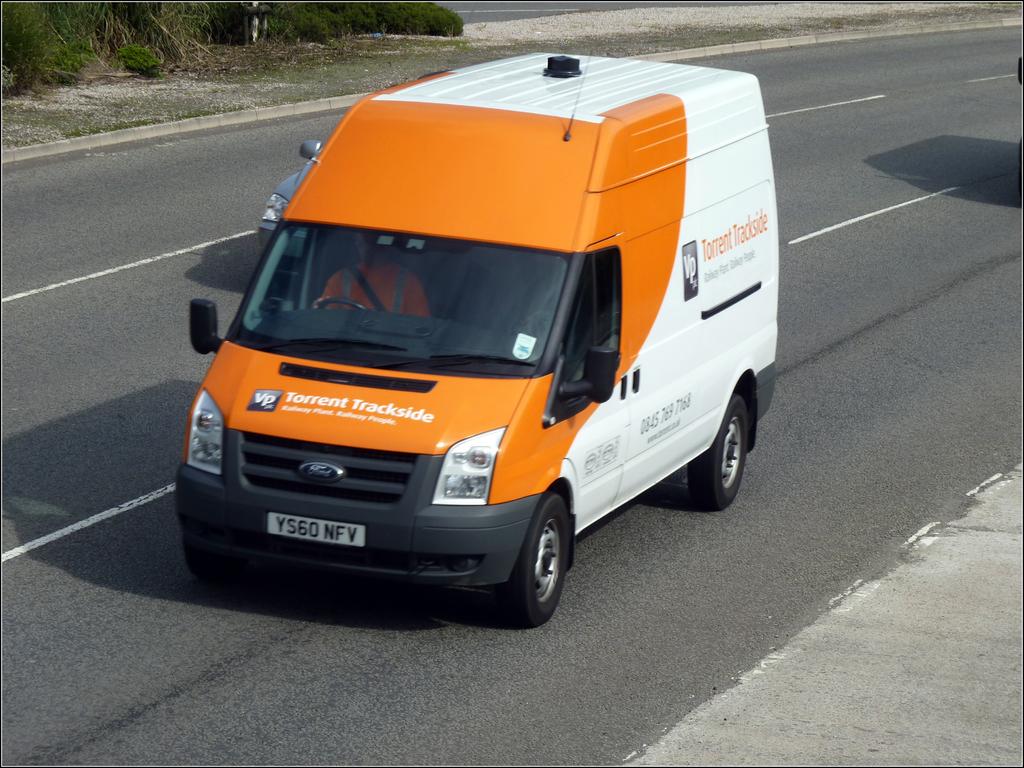What is the company for the van?
Offer a terse response. Torrent trackside. What is the tag number?
Your response must be concise. Ys60 nfv. 